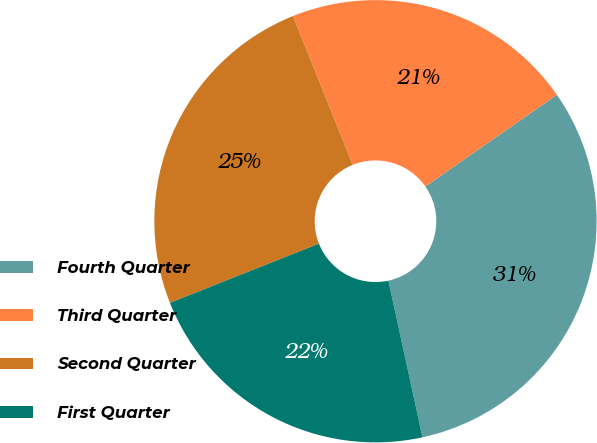<chart> <loc_0><loc_0><loc_500><loc_500><pie_chart><fcel>Fourth Quarter<fcel>Third Quarter<fcel>Second Quarter<fcel>First Quarter<nl><fcel>31.28%<fcel>21.4%<fcel>24.93%<fcel>22.39%<nl></chart> 